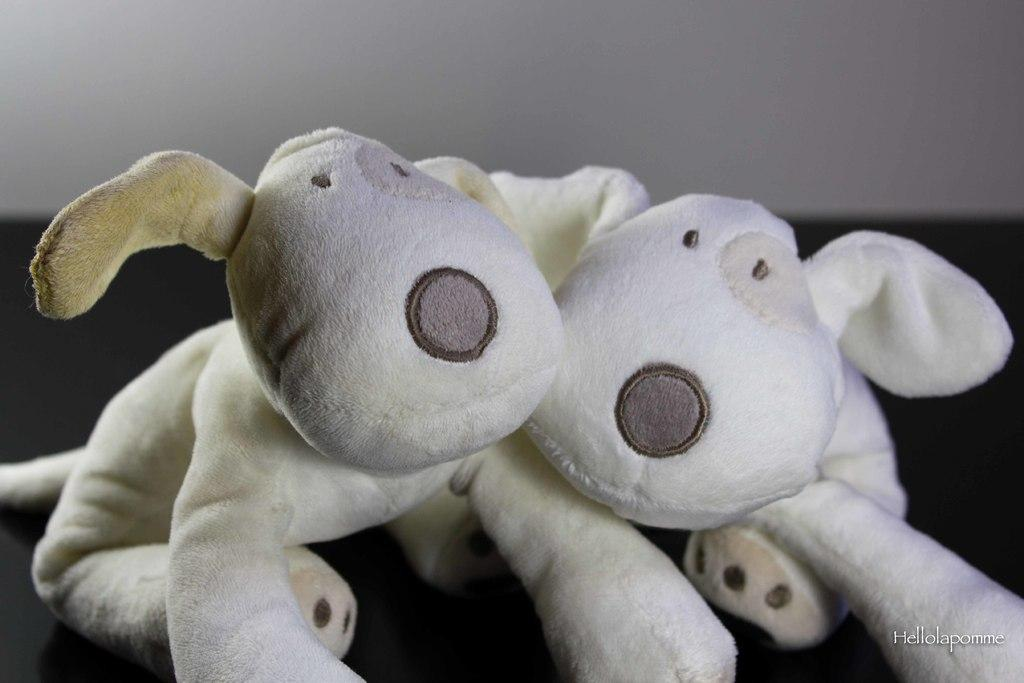What type of objects are present in the image? There are two white-colored soft toys in the image. Can you describe the appearance of the soft toys? The soft toys are white in color. How many babies are crawling on the sand in the image? There are no babies or sand present in the image; it features two white-colored soft toys. 